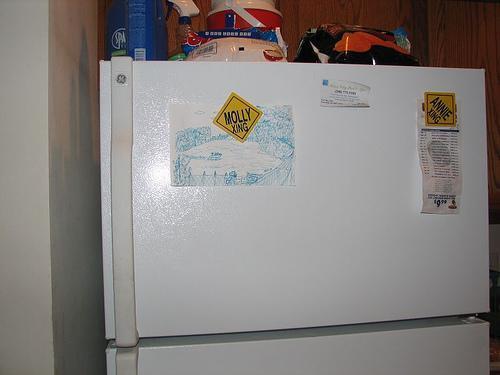How many magnets are on the refrigerator?
Give a very brief answer. 2. 